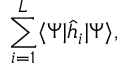<formula> <loc_0><loc_0><loc_500><loc_500>\sum _ { i = 1 } ^ { L } \langle \Psi | \hat { h } _ { i } | \Psi \rangle ,</formula> 